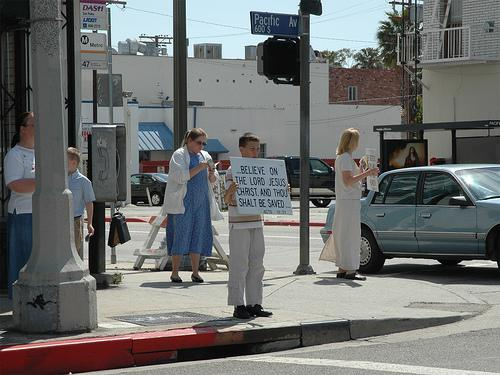Question: what street is he on?
Choices:
A. Atlantic Ave.
B. Main St.
C. Pacific Ave.
D. 1st St.
Answer with the letter. Answer: C Question: how many people?
Choices:
A. 3.
B. 2.
C. 1.
D. 5.
Answer with the letter. Answer: D Question: who is holding the other sign?
Choices:
A. The man.
B. The boy.
C. The lady.
D. The girl.
Answer with the letter. Answer: C Question: what time of day?
Choices:
A. Afternoon.
B. Evening.
C. Midnight.
D. Morning.
Answer with the letter. Answer: D Question: what is the little boy doing?
Choices:
A. Holding a bag.
B. Holding a coat.
C. Holding a sign.
D. Holding a box.
Answer with the letter. Answer: C 